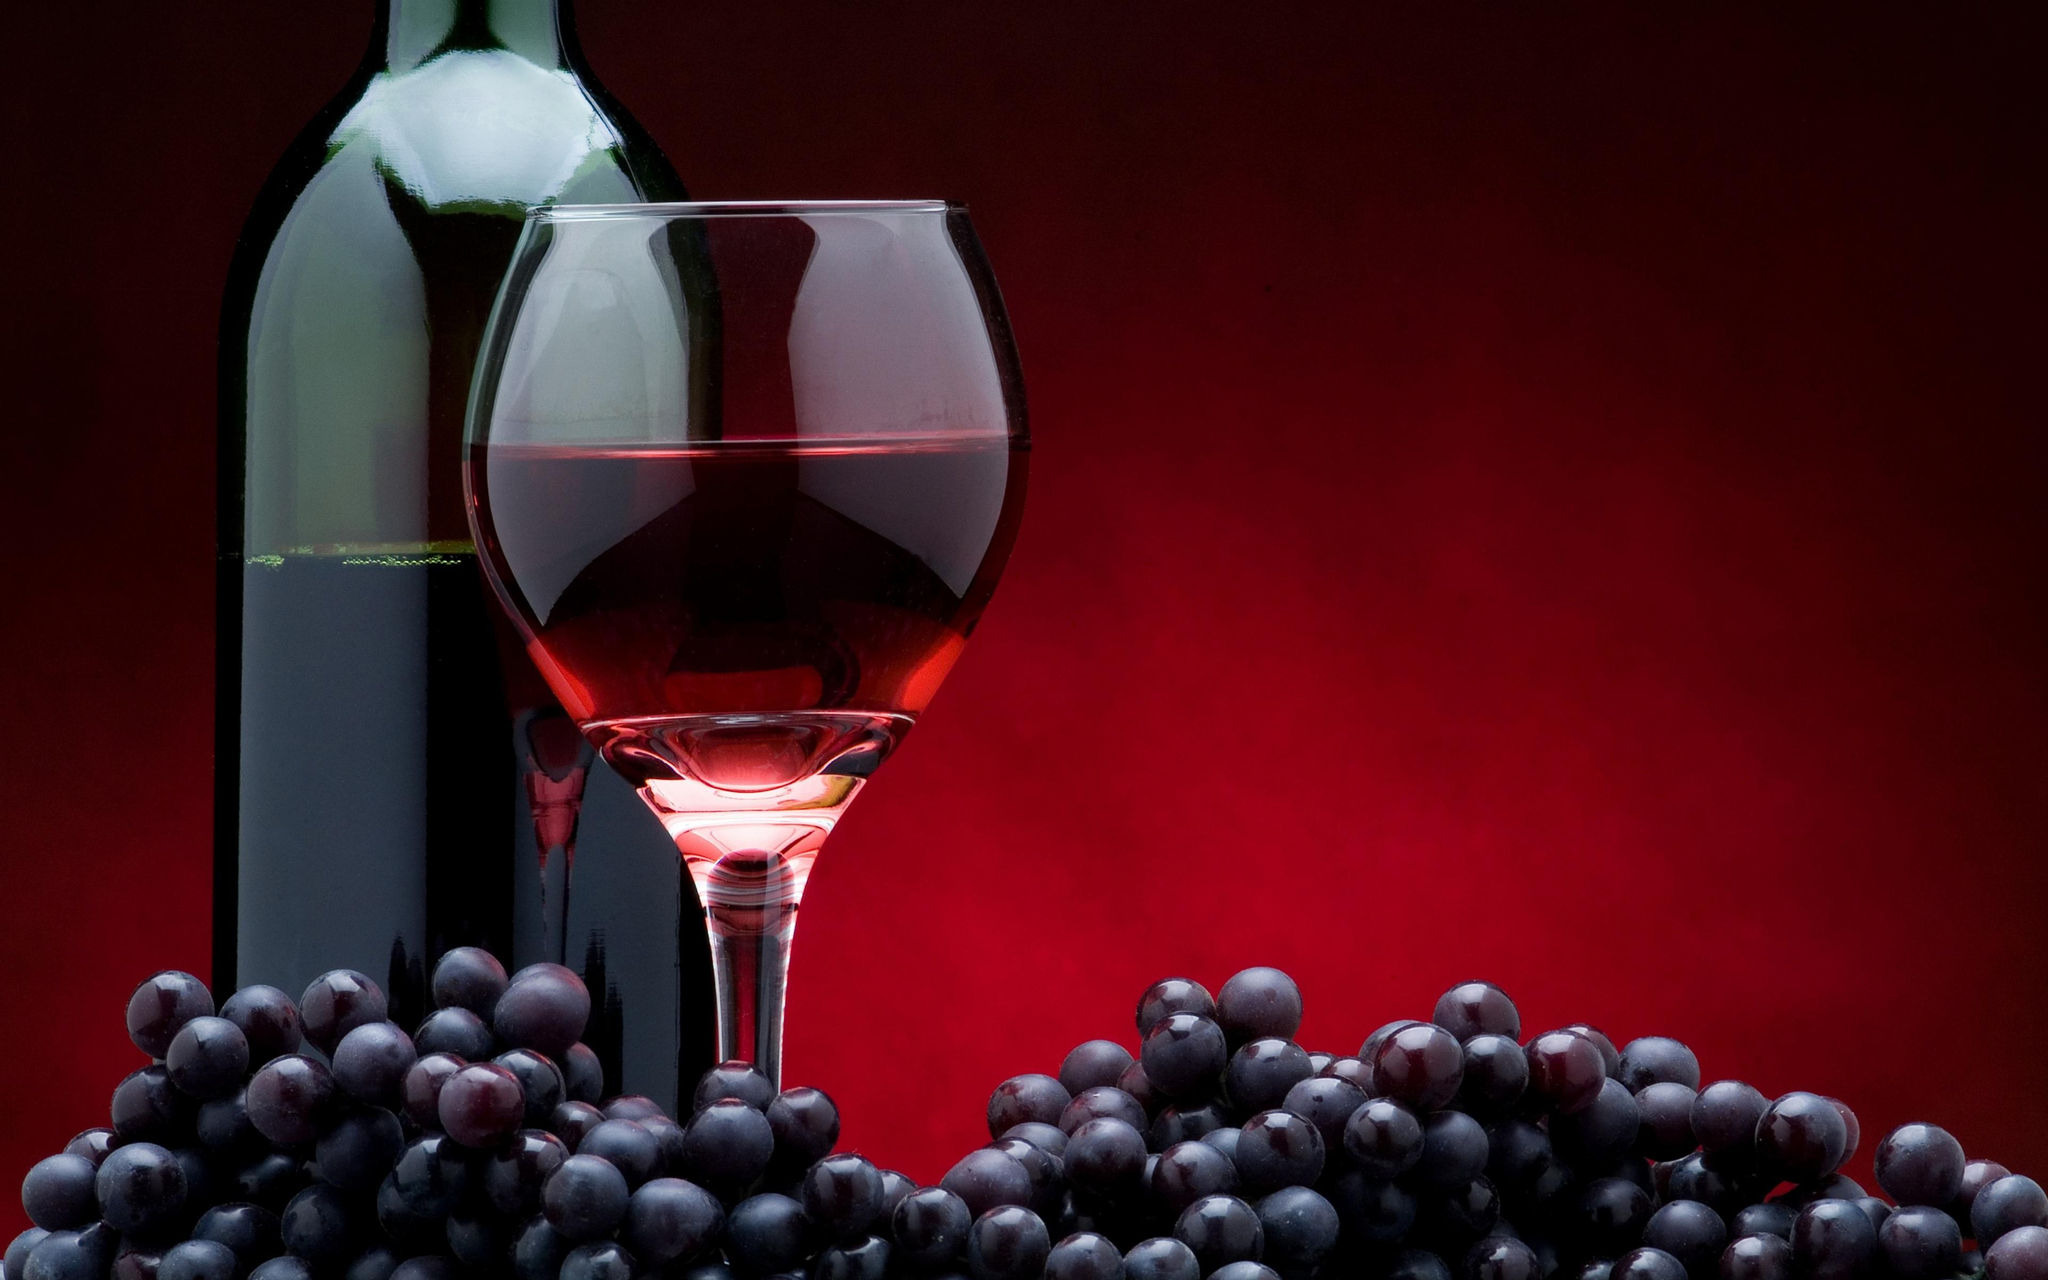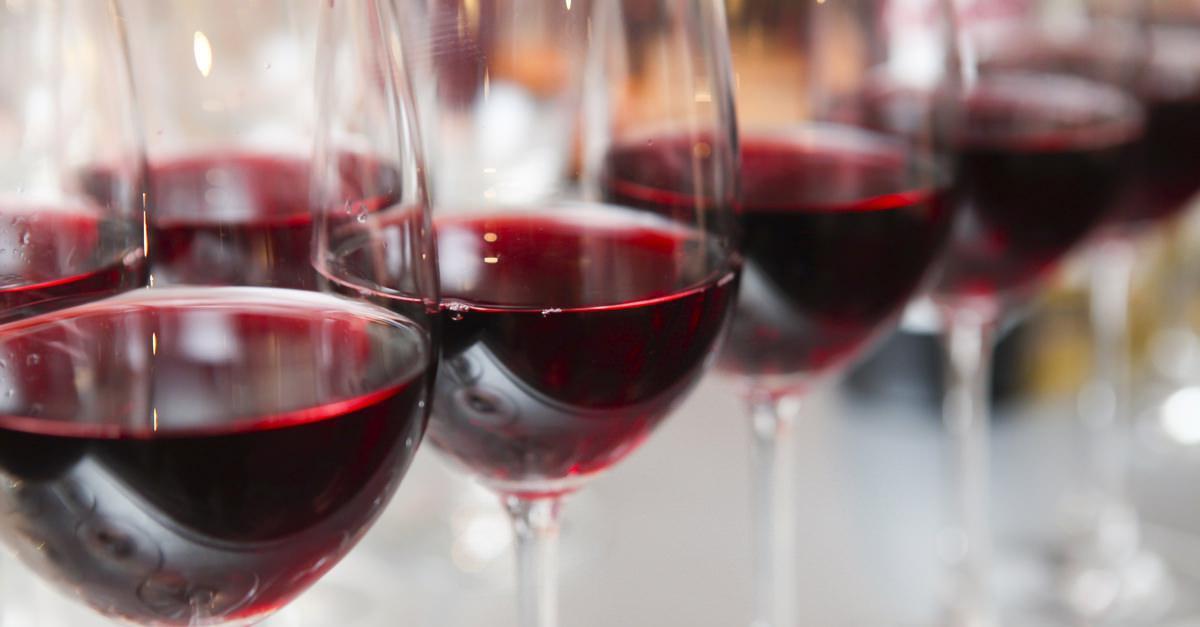The first image is the image on the left, the second image is the image on the right. Assess this claim about the two images: "There are exactly three glasses filled with red wine". Correct or not? Answer yes or no. No. The first image is the image on the left, the second image is the image on the right. Assess this claim about the two images: "An image shows wine flowing into a glass, which stands next to an upright bottle.". Correct or not? Answer yes or no. No. 